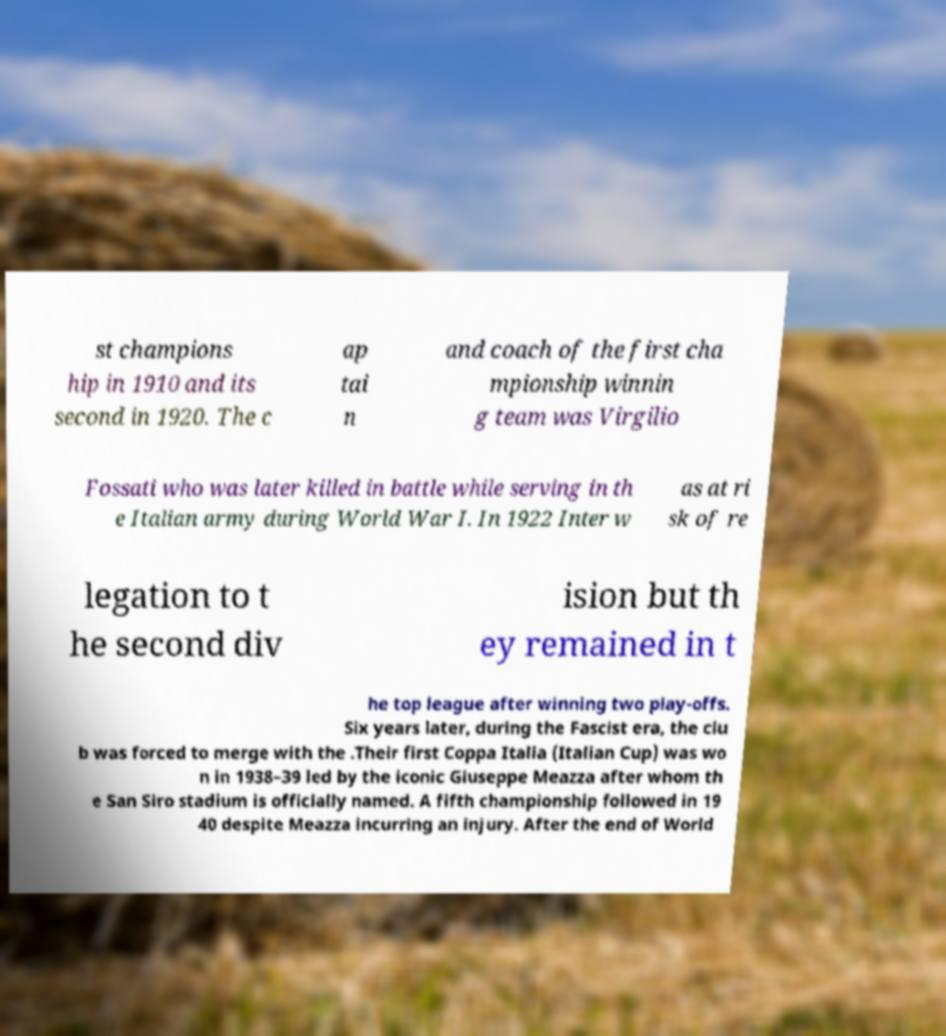For documentation purposes, I need the text within this image transcribed. Could you provide that? st champions hip in 1910 and its second in 1920. The c ap tai n and coach of the first cha mpionship winnin g team was Virgilio Fossati who was later killed in battle while serving in th e Italian army during World War I. In 1922 Inter w as at ri sk of re legation to t he second div ision but th ey remained in t he top league after winning two play-offs. Six years later, during the Fascist era, the clu b was forced to merge with the .Their first Coppa Italia (Italian Cup) was wo n in 1938–39 led by the iconic Giuseppe Meazza after whom th e San Siro stadium is officially named. A fifth championship followed in 19 40 despite Meazza incurring an injury. After the end of World 